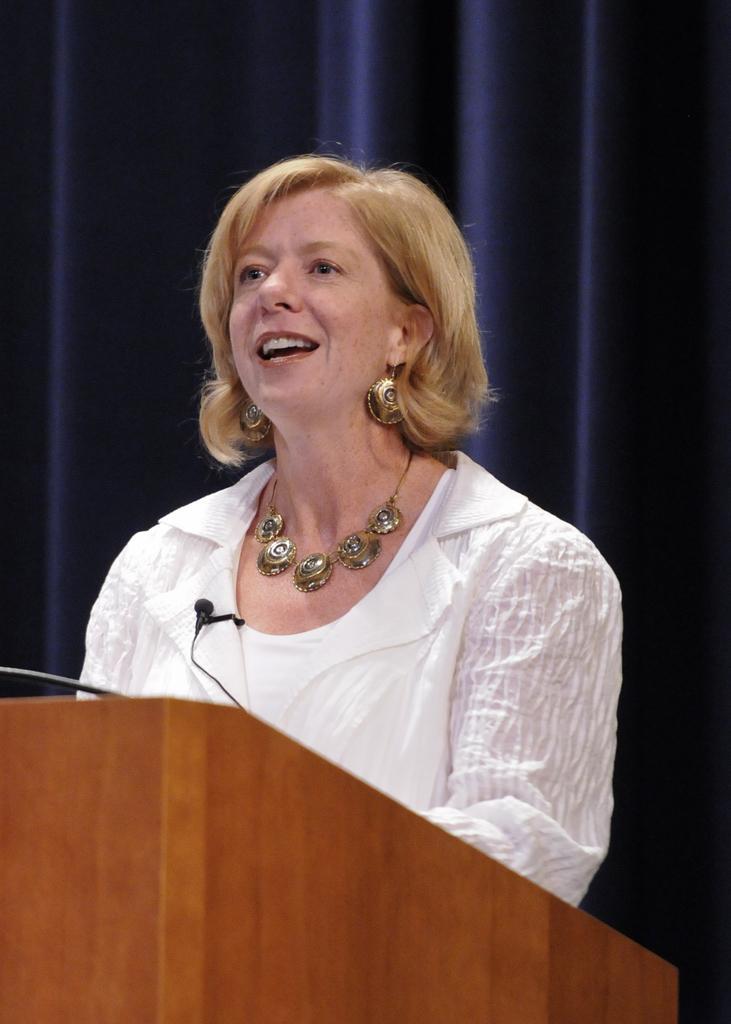Can you describe this image briefly? In this picture there is a woman standing and smiling. In the foreground there is a microphone on the podium. At the back there is a curtain. 